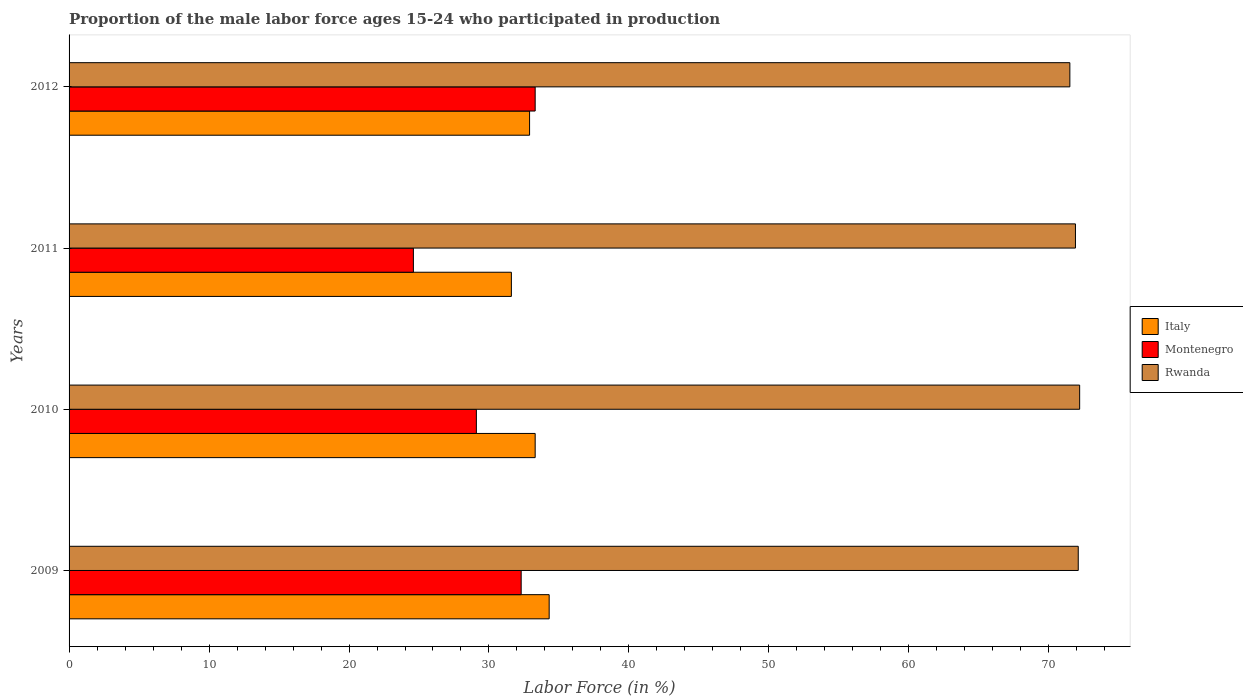How many bars are there on the 3rd tick from the bottom?
Ensure brevity in your answer.  3. What is the label of the 3rd group of bars from the top?
Your answer should be compact. 2010. What is the proportion of the male labor force who participated in production in Montenegro in 2012?
Keep it short and to the point. 33.3. Across all years, what is the maximum proportion of the male labor force who participated in production in Montenegro?
Provide a succinct answer. 33.3. Across all years, what is the minimum proportion of the male labor force who participated in production in Montenegro?
Provide a succinct answer. 24.6. In which year was the proportion of the male labor force who participated in production in Rwanda maximum?
Offer a very short reply. 2010. In which year was the proportion of the male labor force who participated in production in Rwanda minimum?
Keep it short and to the point. 2012. What is the total proportion of the male labor force who participated in production in Italy in the graph?
Your answer should be compact. 132.1. What is the difference between the proportion of the male labor force who participated in production in Rwanda in 2010 and the proportion of the male labor force who participated in production in Italy in 2009?
Offer a terse response. 37.9. What is the average proportion of the male labor force who participated in production in Italy per year?
Offer a very short reply. 33.03. In the year 2012, what is the difference between the proportion of the male labor force who participated in production in Italy and proportion of the male labor force who participated in production in Rwanda?
Make the answer very short. -38.6. In how many years, is the proportion of the male labor force who participated in production in Italy greater than 32 %?
Make the answer very short. 3. What is the ratio of the proportion of the male labor force who participated in production in Montenegro in 2011 to that in 2012?
Keep it short and to the point. 0.74. Is the proportion of the male labor force who participated in production in Italy in 2009 less than that in 2011?
Your answer should be compact. No. Is the difference between the proportion of the male labor force who participated in production in Italy in 2010 and 2012 greater than the difference between the proportion of the male labor force who participated in production in Rwanda in 2010 and 2012?
Provide a succinct answer. No. What is the difference between the highest and the lowest proportion of the male labor force who participated in production in Rwanda?
Your response must be concise. 0.7. In how many years, is the proportion of the male labor force who participated in production in Italy greater than the average proportion of the male labor force who participated in production in Italy taken over all years?
Offer a very short reply. 2. What does the 3rd bar from the top in 2012 represents?
Keep it short and to the point. Italy. What does the 2nd bar from the bottom in 2009 represents?
Your answer should be compact. Montenegro. Is it the case that in every year, the sum of the proportion of the male labor force who participated in production in Montenegro and proportion of the male labor force who participated in production in Italy is greater than the proportion of the male labor force who participated in production in Rwanda?
Provide a succinct answer. No. Are all the bars in the graph horizontal?
Your answer should be compact. Yes. Are the values on the major ticks of X-axis written in scientific E-notation?
Give a very brief answer. No. Does the graph contain any zero values?
Your answer should be compact. No. Does the graph contain grids?
Provide a succinct answer. No. How are the legend labels stacked?
Make the answer very short. Vertical. What is the title of the graph?
Your answer should be compact. Proportion of the male labor force ages 15-24 who participated in production. What is the Labor Force (in %) in Italy in 2009?
Offer a very short reply. 34.3. What is the Labor Force (in %) in Montenegro in 2009?
Offer a terse response. 32.3. What is the Labor Force (in %) in Rwanda in 2009?
Your answer should be compact. 72.1. What is the Labor Force (in %) in Italy in 2010?
Provide a succinct answer. 33.3. What is the Labor Force (in %) in Montenegro in 2010?
Your answer should be compact. 29.1. What is the Labor Force (in %) in Rwanda in 2010?
Make the answer very short. 72.2. What is the Labor Force (in %) of Italy in 2011?
Ensure brevity in your answer.  31.6. What is the Labor Force (in %) in Montenegro in 2011?
Your answer should be very brief. 24.6. What is the Labor Force (in %) in Rwanda in 2011?
Ensure brevity in your answer.  71.9. What is the Labor Force (in %) of Italy in 2012?
Provide a short and direct response. 32.9. What is the Labor Force (in %) of Montenegro in 2012?
Offer a very short reply. 33.3. What is the Labor Force (in %) of Rwanda in 2012?
Ensure brevity in your answer.  71.5. Across all years, what is the maximum Labor Force (in %) in Italy?
Give a very brief answer. 34.3. Across all years, what is the maximum Labor Force (in %) of Montenegro?
Make the answer very short. 33.3. Across all years, what is the maximum Labor Force (in %) of Rwanda?
Your answer should be compact. 72.2. Across all years, what is the minimum Labor Force (in %) in Italy?
Keep it short and to the point. 31.6. Across all years, what is the minimum Labor Force (in %) in Montenegro?
Ensure brevity in your answer.  24.6. Across all years, what is the minimum Labor Force (in %) in Rwanda?
Give a very brief answer. 71.5. What is the total Labor Force (in %) of Italy in the graph?
Provide a succinct answer. 132.1. What is the total Labor Force (in %) in Montenegro in the graph?
Your answer should be compact. 119.3. What is the total Labor Force (in %) of Rwanda in the graph?
Give a very brief answer. 287.7. What is the difference between the Labor Force (in %) in Italy in 2009 and that in 2010?
Ensure brevity in your answer.  1. What is the difference between the Labor Force (in %) in Montenegro in 2009 and that in 2010?
Ensure brevity in your answer.  3.2. What is the difference between the Labor Force (in %) of Rwanda in 2009 and that in 2010?
Offer a terse response. -0.1. What is the difference between the Labor Force (in %) in Rwanda in 2009 and that in 2011?
Provide a succinct answer. 0.2. What is the difference between the Labor Force (in %) in Montenegro in 2010 and that in 2011?
Keep it short and to the point. 4.5. What is the difference between the Labor Force (in %) of Rwanda in 2010 and that in 2011?
Offer a terse response. 0.3. What is the difference between the Labor Force (in %) in Rwanda in 2010 and that in 2012?
Ensure brevity in your answer.  0.7. What is the difference between the Labor Force (in %) in Italy in 2011 and that in 2012?
Offer a very short reply. -1.3. What is the difference between the Labor Force (in %) in Montenegro in 2011 and that in 2012?
Offer a very short reply. -8.7. What is the difference between the Labor Force (in %) in Italy in 2009 and the Labor Force (in %) in Montenegro in 2010?
Make the answer very short. 5.2. What is the difference between the Labor Force (in %) of Italy in 2009 and the Labor Force (in %) of Rwanda in 2010?
Ensure brevity in your answer.  -37.9. What is the difference between the Labor Force (in %) in Montenegro in 2009 and the Labor Force (in %) in Rwanda in 2010?
Offer a terse response. -39.9. What is the difference between the Labor Force (in %) of Italy in 2009 and the Labor Force (in %) of Rwanda in 2011?
Give a very brief answer. -37.6. What is the difference between the Labor Force (in %) of Montenegro in 2009 and the Labor Force (in %) of Rwanda in 2011?
Give a very brief answer. -39.6. What is the difference between the Labor Force (in %) of Italy in 2009 and the Labor Force (in %) of Rwanda in 2012?
Keep it short and to the point. -37.2. What is the difference between the Labor Force (in %) of Montenegro in 2009 and the Labor Force (in %) of Rwanda in 2012?
Your answer should be very brief. -39.2. What is the difference between the Labor Force (in %) of Italy in 2010 and the Labor Force (in %) of Montenegro in 2011?
Offer a very short reply. 8.7. What is the difference between the Labor Force (in %) of Italy in 2010 and the Labor Force (in %) of Rwanda in 2011?
Give a very brief answer. -38.6. What is the difference between the Labor Force (in %) of Montenegro in 2010 and the Labor Force (in %) of Rwanda in 2011?
Ensure brevity in your answer.  -42.8. What is the difference between the Labor Force (in %) in Italy in 2010 and the Labor Force (in %) in Rwanda in 2012?
Ensure brevity in your answer.  -38.2. What is the difference between the Labor Force (in %) of Montenegro in 2010 and the Labor Force (in %) of Rwanda in 2012?
Your answer should be very brief. -42.4. What is the difference between the Labor Force (in %) in Italy in 2011 and the Labor Force (in %) in Rwanda in 2012?
Provide a short and direct response. -39.9. What is the difference between the Labor Force (in %) in Montenegro in 2011 and the Labor Force (in %) in Rwanda in 2012?
Make the answer very short. -46.9. What is the average Labor Force (in %) in Italy per year?
Your answer should be compact. 33.02. What is the average Labor Force (in %) in Montenegro per year?
Your response must be concise. 29.82. What is the average Labor Force (in %) of Rwanda per year?
Make the answer very short. 71.92. In the year 2009, what is the difference between the Labor Force (in %) of Italy and Labor Force (in %) of Rwanda?
Provide a succinct answer. -37.8. In the year 2009, what is the difference between the Labor Force (in %) in Montenegro and Labor Force (in %) in Rwanda?
Offer a terse response. -39.8. In the year 2010, what is the difference between the Labor Force (in %) of Italy and Labor Force (in %) of Montenegro?
Provide a succinct answer. 4.2. In the year 2010, what is the difference between the Labor Force (in %) in Italy and Labor Force (in %) in Rwanda?
Ensure brevity in your answer.  -38.9. In the year 2010, what is the difference between the Labor Force (in %) of Montenegro and Labor Force (in %) of Rwanda?
Offer a very short reply. -43.1. In the year 2011, what is the difference between the Labor Force (in %) in Italy and Labor Force (in %) in Rwanda?
Make the answer very short. -40.3. In the year 2011, what is the difference between the Labor Force (in %) of Montenegro and Labor Force (in %) of Rwanda?
Your response must be concise. -47.3. In the year 2012, what is the difference between the Labor Force (in %) of Italy and Labor Force (in %) of Montenegro?
Offer a terse response. -0.4. In the year 2012, what is the difference between the Labor Force (in %) in Italy and Labor Force (in %) in Rwanda?
Keep it short and to the point. -38.6. In the year 2012, what is the difference between the Labor Force (in %) of Montenegro and Labor Force (in %) of Rwanda?
Your response must be concise. -38.2. What is the ratio of the Labor Force (in %) of Montenegro in 2009 to that in 2010?
Give a very brief answer. 1.11. What is the ratio of the Labor Force (in %) in Italy in 2009 to that in 2011?
Your answer should be compact. 1.09. What is the ratio of the Labor Force (in %) of Montenegro in 2009 to that in 2011?
Give a very brief answer. 1.31. What is the ratio of the Labor Force (in %) in Italy in 2009 to that in 2012?
Make the answer very short. 1.04. What is the ratio of the Labor Force (in %) of Montenegro in 2009 to that in 2012?
Make the answer very short. 0.97. What is the ratio of the Labor Force (in %) in Rwanda in 2009 to that in 2012?
Provide a succinct answer. 1.01. What is the ratio of the Labor Force (in %) of Italy in 2010 to that in 2011?
Your answer should be very brief. 1.05. What is the ratio of the Labor Force (in %) of Montenegro in 2010 to that in 2011?
Give a very brief answer. 1.18. What is the ratio of the Labor Force (in %) in Italy in 2010 to that in 2012?
Make the answer very short. 1.01. What is the ratio of the Labor Force (in %) of Montenegro in 2010 to that in 2012?
Provide a short and direct response. 0.87. What is the ratio of the Labor Force (in %) of Rwanda in 2010 to that in 2012?
Make the answer very short. 1.01. What is the ratio of the Labor Force (in %) of Italy in 2011 to that in 2012?
Provide a succinct answer. 0.96. What is the ratio of the Labor Force (in %) of Montenegro in 2011 to that in 2012?
Your answer should be compact. 0.74. What is the ratio of the Labor Force (in %) in Rwanda in 2011 to that in 2012?
Keep it short and to the point. 1.01. What is the difference between the highest and the second highest Labor Force (in %) in Montenegro?
Your answer should be compact. 1. What is the difference between the highest and the second highest Labor Force (in %) of Rwanda?
Give a very brief answer. 0.1. What is the difference between the highest and the lowest Labor Force (in %) of Italy?
Offer a terse response. 2.7. 